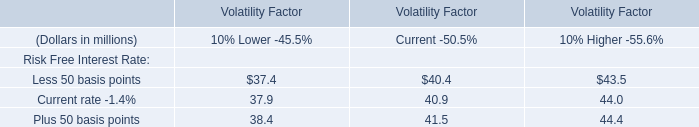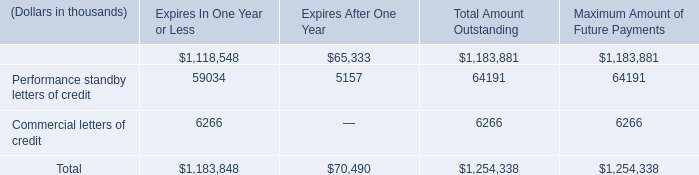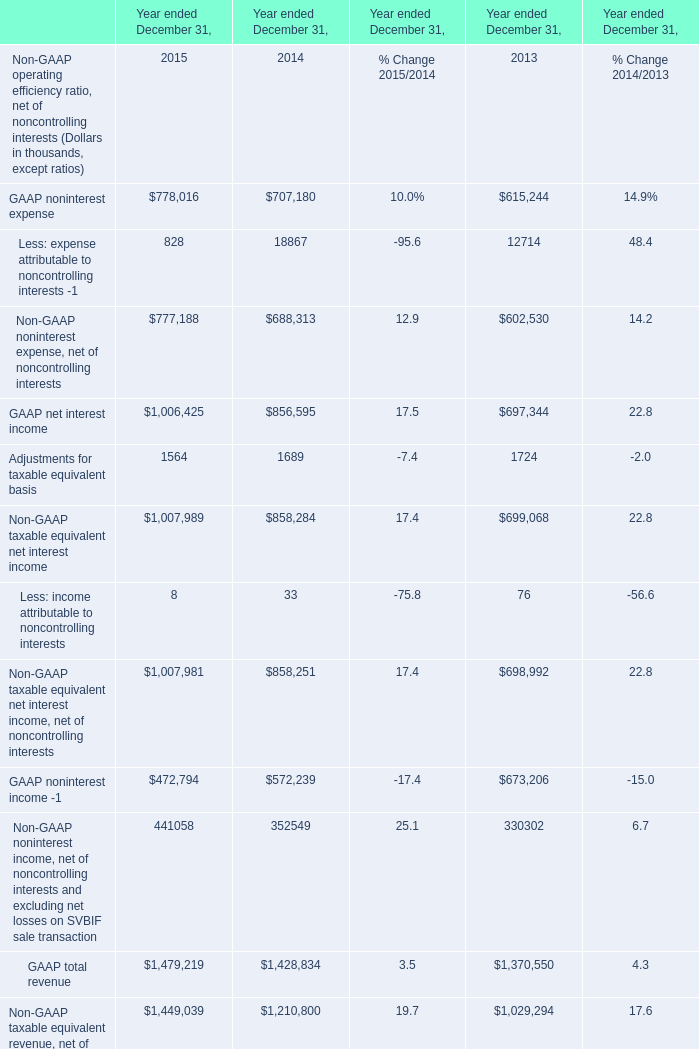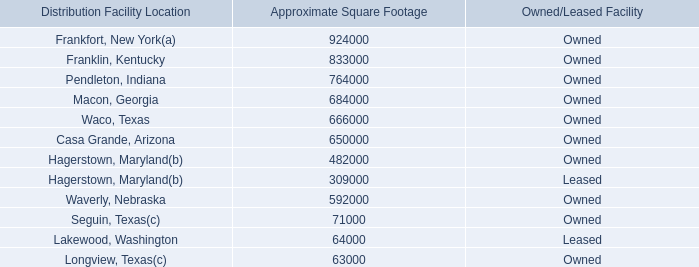What is the average amount of GAAP noninterest expense of Year ended December 31, 2015, and Hagerstown, Maryland of Approximate Square Footage ? 
Computations: ((778016.0 + 309000.0) / 2)
Answer: 543508.0. 